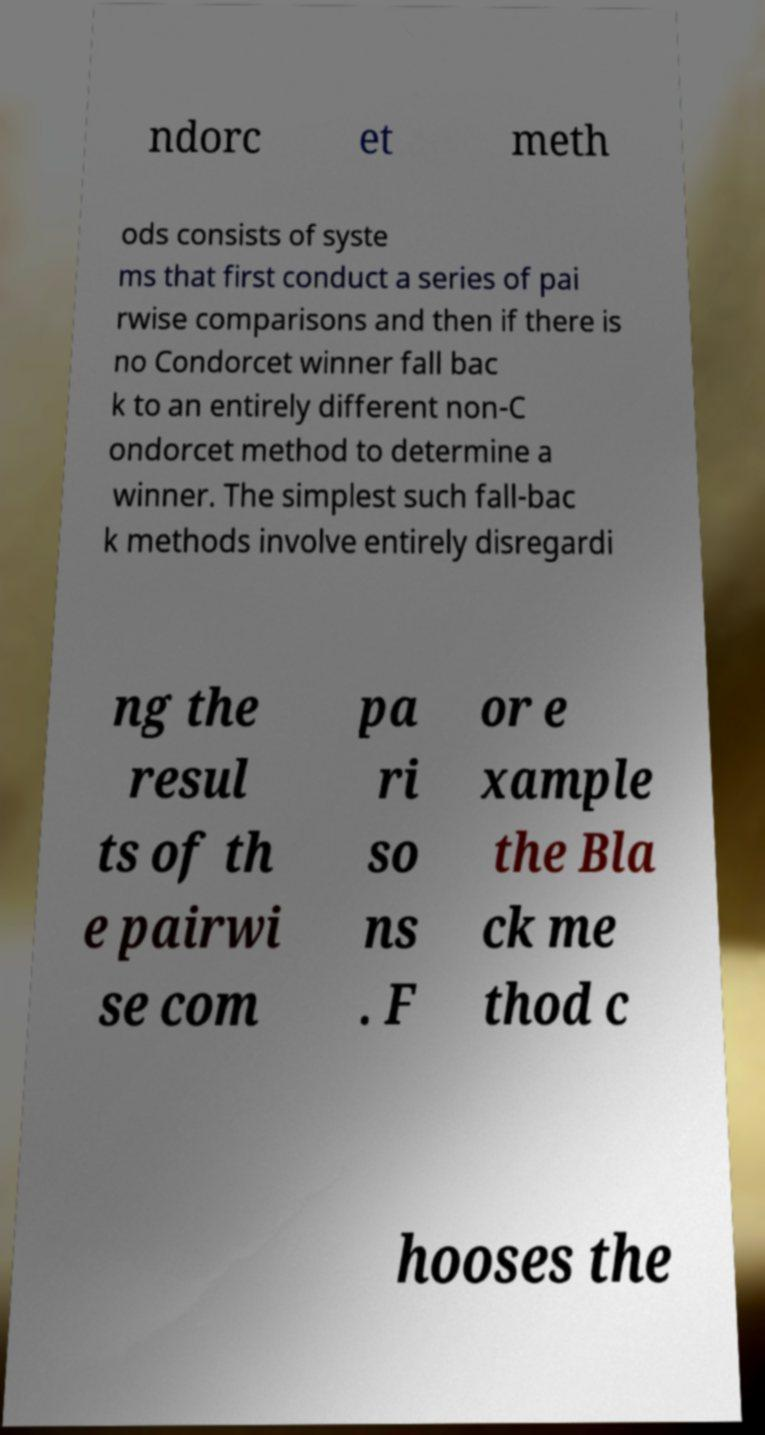What messages or text are displayed in this image? I need them in a readable, typed format. ndorc et meth ods consists of syste ms that first conduct a series of pai rwise comparisons and then if there is no Condorcet winner fall bac k to an entirely different non-C ondorcet method to determine a winner. The simplest such fall-bac k methods involve entirely disregardi ng the resul ts of th e pairwi se com pa ri so ns . F or e xample the Bla ck me thod c hooses the 